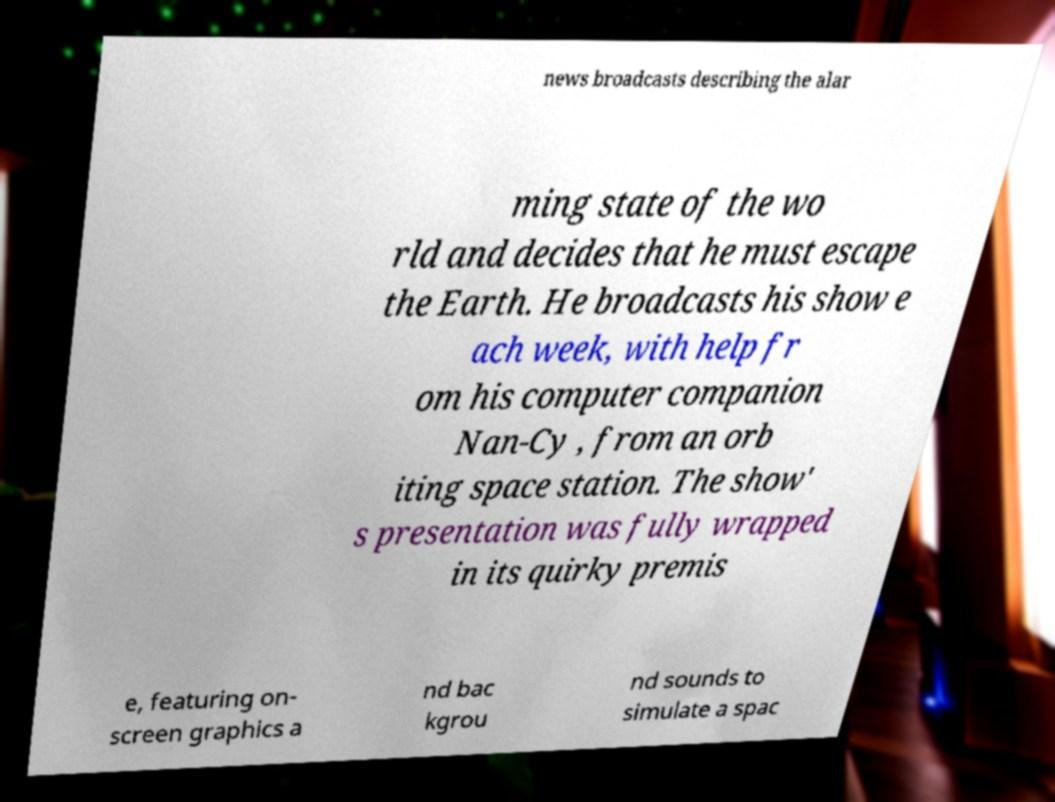For documentation purposes, I need the text within this image transcribed. Could you provide that? news broadcasts describing the alar ming state of the wo rld and decides that he must escape the Earth. He broadcasts his show e ach week, with help fr om his computer companion Nan-Cy , from an orb iting space station. The show' s presentation was fully wrapped in its quirky premis e, featuring on- screen graphics a nd bac kgrou nd sounds to simulate a spac 